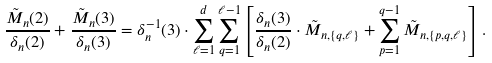Convert formula to latex. <formula><loc_0><loc_0><loc_500><loc_500>\frac { \tilde { M } _ { n } ( 2 ) } { \delta _ { n } ( 2 ) } + \frac { \tilde { M } _ { n } ( 3 ) } { \delta _ { n } ( 3 ) } = \delta ^ { - 1 } _ { n } ( 3 ) \cdot \sum _ { \ell = 1 } ^ { d } \sum _ { q = 1 } ^ { \ell - 1 } \left [ \frac { \delta _ { n } ( 3 ) } { \delta _ { n } ( 2 ) } \cdot \tilde { M } _ { n , \{ q , \ell \} } + \sum _ { p = 1 } ^ { q - 1 } \tilde { M } _ { n , \{ p , q , \ell \} } \right ] .</formula> 